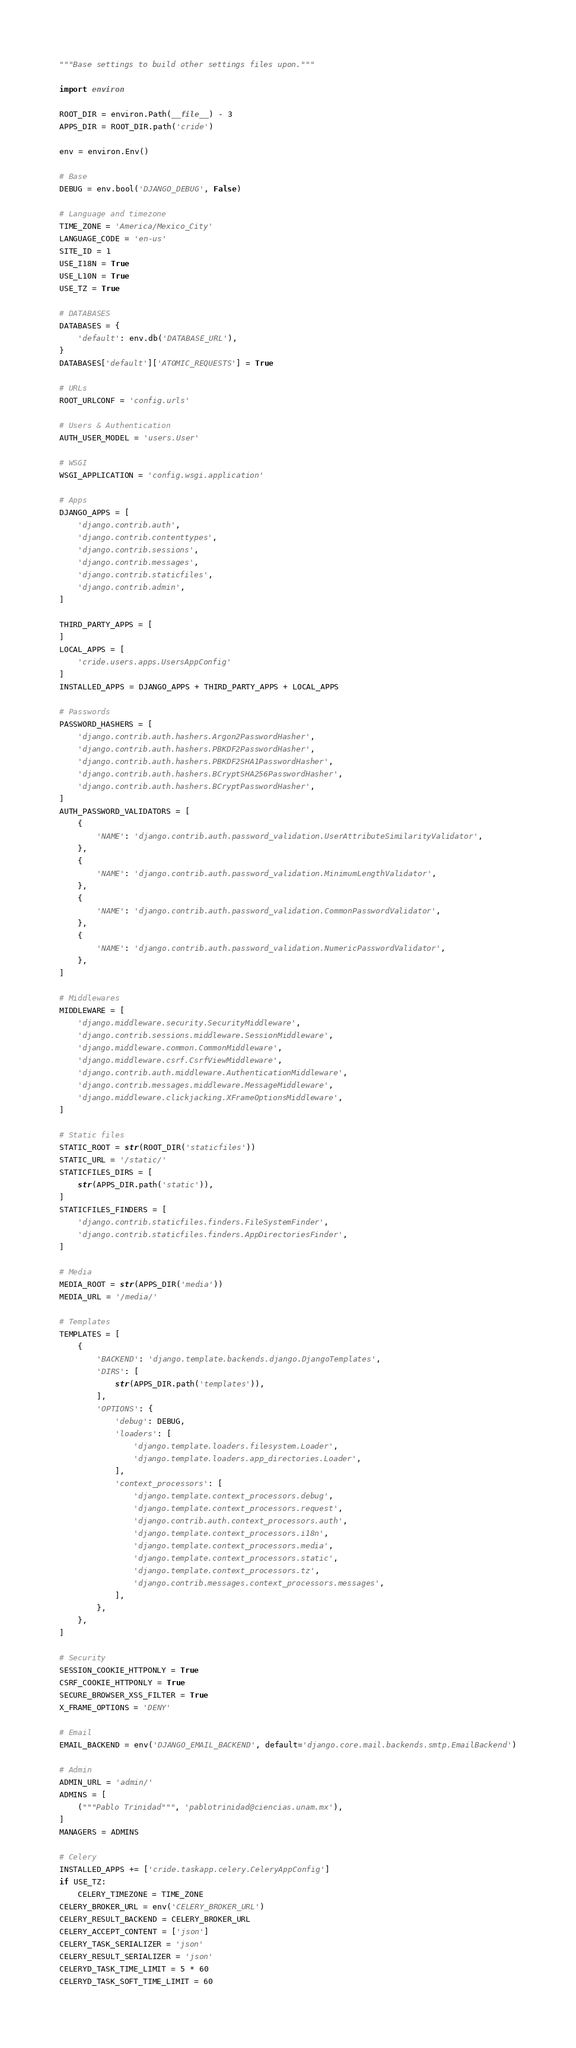<code> <loc_0><loc_0><loc_500><loc_500><_Python_>"""Base settings to build other settings files upon."""

import environ

ROOT_DIR = environ.Path(__file__) - 3
APPS_DIR = ROOT_DIR.path('cride')

env = environ.Env()

# Base
DEBUG = env.bool('DJANGO_DEBUG', False)

# Language and timezone
TIME_ZONE = 'America/Mexico_City'
LANGUAGE_CODE = 'en-us'
SITE_ID = 1
USE_I18N = True
USE_L10N = True
USE_TZ = True

# DATABASES
DATABASES = {
    'default': env.db('DATABASE_URL'),
}
DATABASES['default']['ATOMIC_REQUESTS'] = True

# URLs
ROOT_URLCONF = 'config.urls'

# Users & Authentication
AUTH_USER_MODEL = 'users.User'

# WSGI
WSGI_APPLICATION = 'config.wsgi.application'

# Apps
DJANGO_APPS = [
    'django.contrib.auth',
    'django.contrib.contenttypes',
    'django.contrib.sessions',
    'django.contrib.messages',
    'django.contrib.staticfiles',
    'django.contrib.admin',
]

THIRD_PARTY_APPS = [
]
LOCAL_APPS = [
    'cride.users.apps.UsersAppConfig'
]
INSTALLED_APPS = DJANGO_APPS + THIRD_PARTY_APPS + LOCAL_APPS

# Passwords
PASSWORD_HASHERS = [
    'django.contrib.auth.hashers.Argon2PasswordHasher',
    'django.contrib.auth.hashers.PBKDF2PasswordHasher',
    'django.contrib.auth.hashers.PBKDF2SHA1PasswordHasher',
    'django.contrib.auth.hashers.BCryptSHA256PasswordHasher',
    'django.contrib.auth.hashers.BCryptPasswordHasher',
]
AUTH_PASSWORD_VALIDATORS = [
    {
        'NAME': 'django.contrib.auth.password_validation.UserAttributeSimilarityValidator',
    },
    {
        'NAME': 'django.contrib.auth.password_validation.MinimumLengthValidator',
    },
    {
        'NAME': 'django.contrib.auth.password_validation.CommonPasswordValidator',
    },
    {
        'NAME': 'django.contrib.auth.password_validation.NumericPasswordValidator',
    },
]

# Middlewares
MIDDLEWARE = [
    'django.middleware.security.SecurityMiddleware',
    'django.contrib.sessions.middleware.SessionMiddleware',
    'django.middleware.common.CommonMiddleware',
    'django.middleware.csrf.CsrfViewMiddleware',
    'django.contrib.auth.middleware.AuthenticationMiddleware',
    'django.contrib.messages.middleware.MessageMiddleware',
    'django.middleware.clickjacking.XFrameOptionsMiddleware',
]

# Static files
STATIC_ROOT = str(ROOT_DIR('staticfiles'))
STATIC_URL = '/static/'
STATICFILES_DIRS = [
    str(APPS_DIR.path('static')),
]
STATICFILES_FINDERS = [
    'django.contrib.staticfiles.finders.FileSystemFinder',
    'django.contrib.staticfiles.finders.AppDirectoriesFinder',
]

# Media
MEDIA_ROOT = str(APPS_DIR('media'))
MEDIA_URL = '/media/'

# Templates
TEMPLATES = [
    {
        'BACKEND': 'django.template.backends.django.DjangoTemplates',
        'DIRS': [
            str(APPS_DIR.path('templates')),
        ],
        'OPTIONS': {
            'debug': DEBUG,
            'loaders': [
                'django.template.loaders.filesystem.Loader',
                'django.template.loaders.app_directories.Loader',
            ],
            'context_processors': [
                'django.template.context_processors.debug',
                'django.template.context_processors.request',
                'django.contrib.auth.context_processors.auth',
                'django.template.context_processors.i18n',
                'django.template.context_processors.media',
                'django.template.context_processors.static',
                'django.template.context_processors.tz',
                'django.contrib.messages.context_processors.messages',
            ],
        },
    },
]

# Security
SESSION_COOKIE_HTTPONLY = True
CSRF_COOKIE_HTTPONLY = True
SECURE_BROWSER_XSS_FILTER = True
X_FRAME_OPTIONS = 'DENY'

# Email
EMAIL_BACKEND = env('DJANGO_EMAIL_BACKEND', default='django.core.mail.backends.smtp.EmailBackend')

# Admin
ADMIN_URL = 'admin/'
ADMINS = [
    ("""Pablo Trinidad""", 'pablotrinidad@ciencias.unam.mx'),
]
MANAGERS = ADMINS

# Celery
INSTALLED_APPS += ['cride.taskapp.celery.CeleryAppConfig']
if USE_TZ:
    CELERY_TIMEZONE = TIME_ZONE
CELERY_BROKER_URL = env('CELERY_BROKER_URL')
CELERY_RESULT_BACKEND = CELERY_BROKER_URL
CELERY_ACCEPT_CONTENT = ['json']
CELERY_TASK_SERIALIZER = 'json'
CELERY_RESULT_SERIALIZER = 'json'
CELERYD_TASK_TIME_LIMIT = 5 * 60
CELERYD_TASK_SOFT_TIME_LIMIT = 60
</code> 